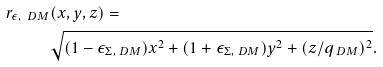<formula> <loc_0><loc_0><loc_500><loc_500>r _ { \epsilon , \ D M } & ( x , y , z ) = \\ & \sqrt { ( 1 - \epsilon _ { \Sigma , \ D M } ) x ^ { 2 } + ( 1 + \epsilon _ { \Sigma , \ D M } ) y ^ { 2 } + ( z / q _ { \ D M } ) ^ { 2 } } .</formula> 